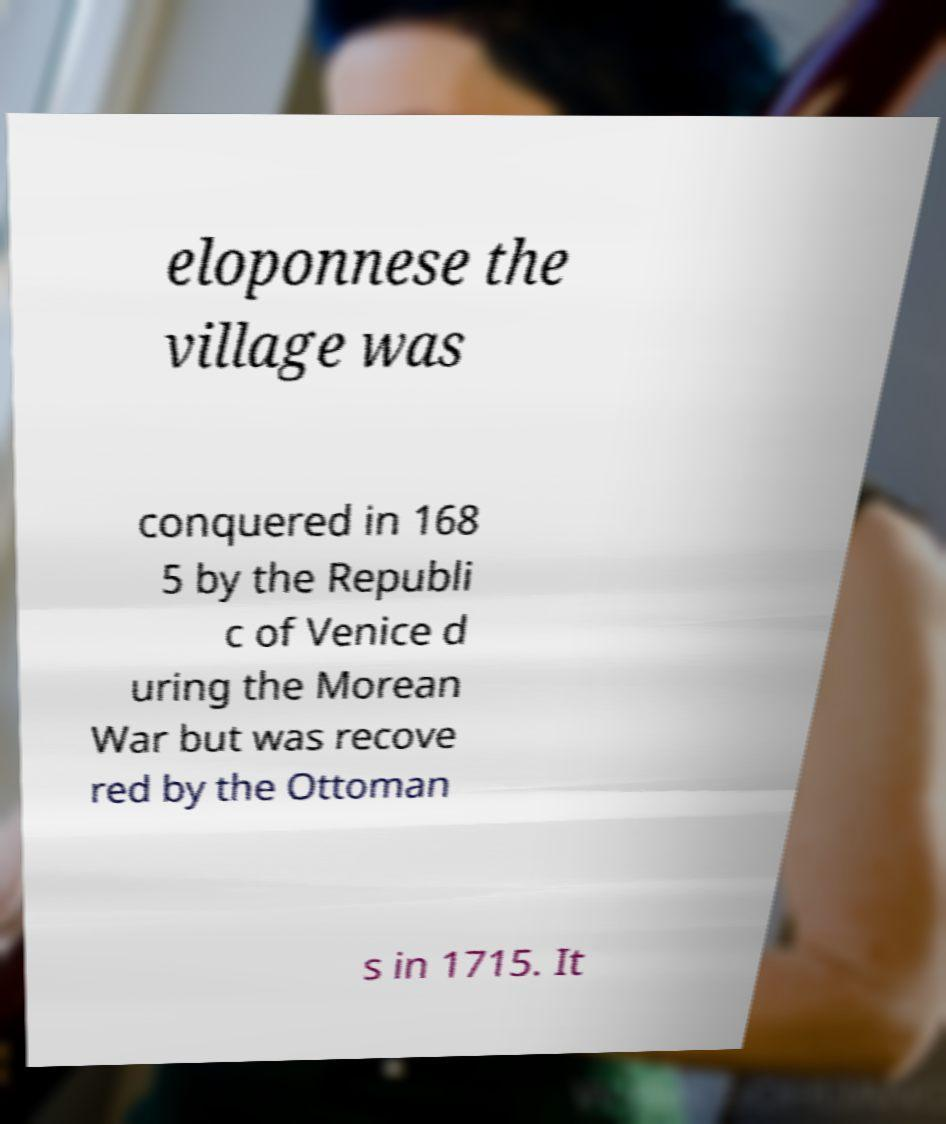Can you accurately transcribe the text from the provided image for me? eloponnese the village was conquered in 168 5 by the Republi c of Venice d uring the Morean War but was recove red by the Ottoman s in 1715. It 